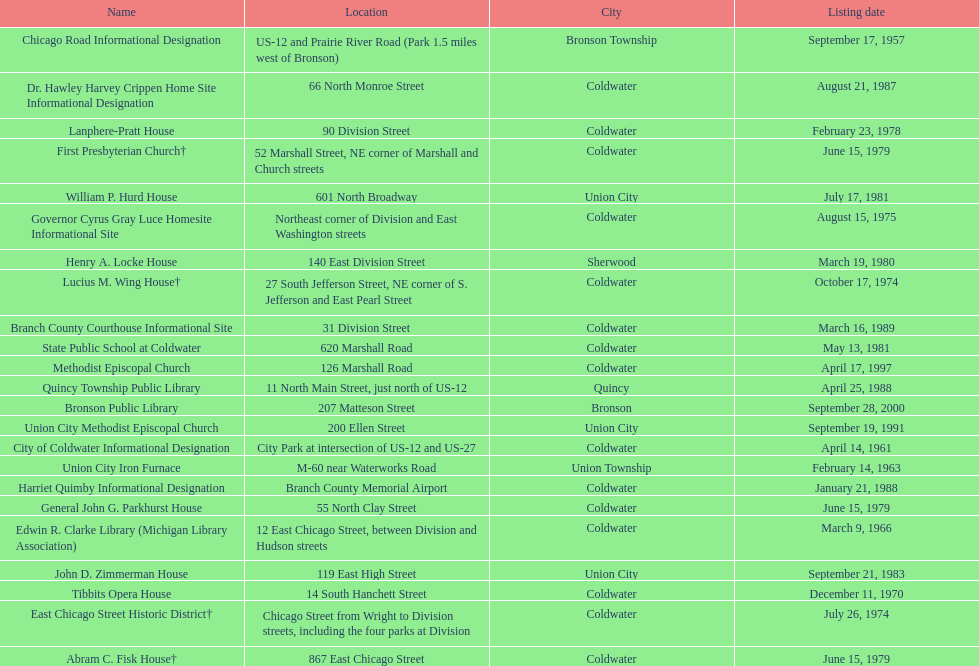Which city has the largest number of historic sites? Coldwater. 